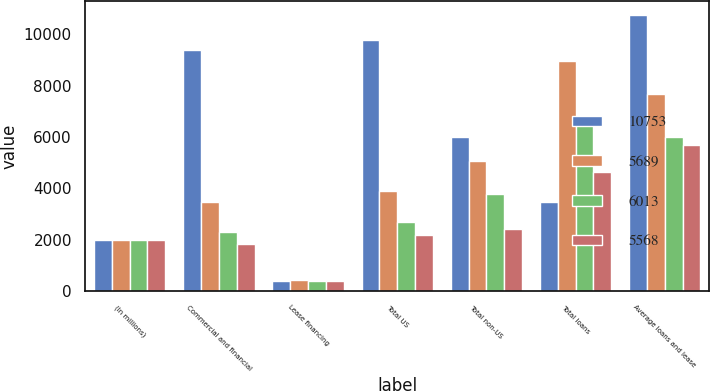Convert chart. <chart><loc_0><loc_0><loc_500><loc_500><stacked_bar_chart><ecel><fcel>(In millions)<fcel>Commercial and financial<fcel>Lease financing<fcel>Total US<fcel>Total non-US<fcel>Total loans<fcel>Average loans and lease<nl><fcel>10753<fcel>2007<fcel>9402<fcel>396<fcel>9798<fcel>6004<fcel>3480<fcel>10753<nl><fcel>5689<fcel>2006<fcel>3480<fcel>415<fcel>3895<fcel>5051<fcel>8946<fcel>7670<nl><fcel>6013<fcel>2005<fcel>2298<fcel>404<fcel>2702<fcel>3780<fcel>6482<fcel>6013<nl><fcel>5568<fcel>2004<fcel>1826<fcel>373<fcel>2199<fcel>2430<fcel>4629<fcel>5689<nl></chart> 